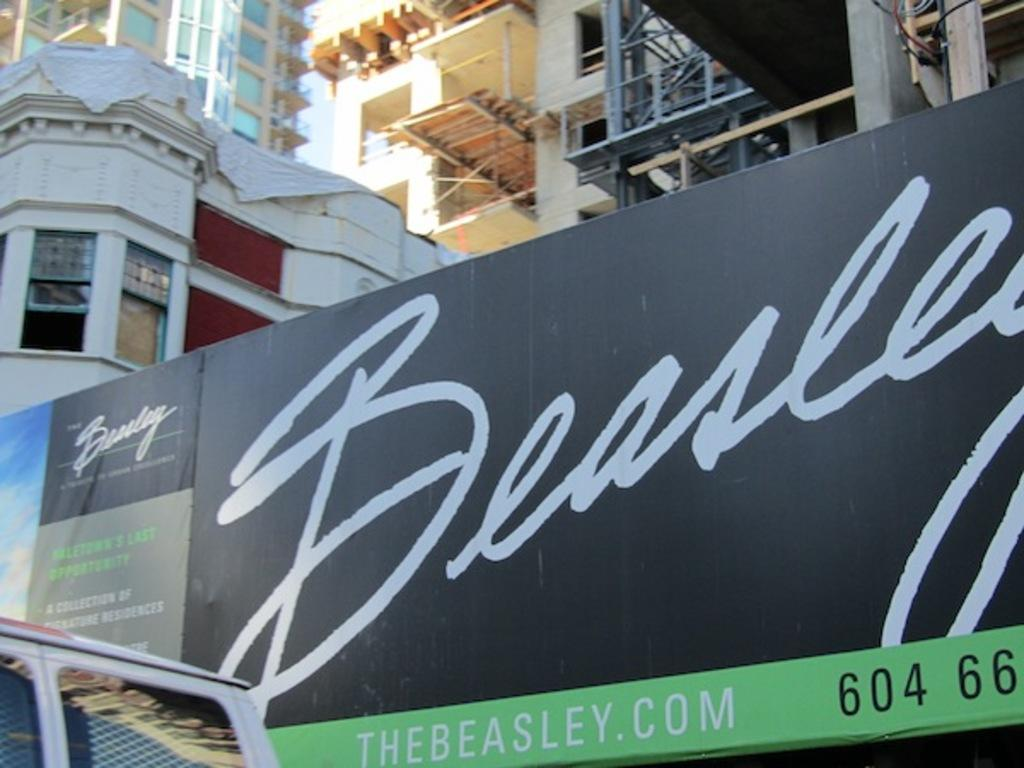What can be seen in the bottom left-hand corner of the image? There is a vehicle in the bottom left-hand corner of the image. What is located in the middle of the image? There is a board with text in the middle of the image. What type of structures are visible at the top of the image? There are buildings visible at the top of the image. What type of creature is sitting on the plate in the image? There is no plate or creature present in the image. 